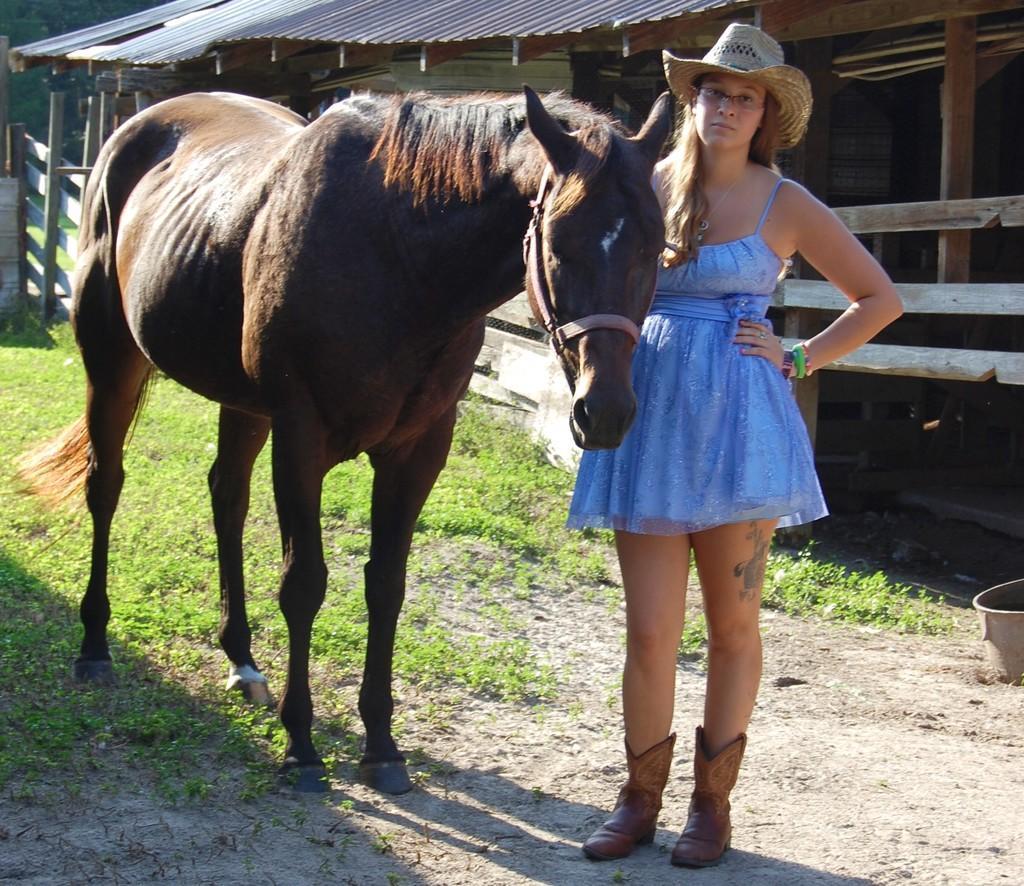Describe this image in one or two sentences. A horse and a lady, lady who is wearing a blue gown and a hat. Behind them there is a roof like shade and also some grass under the horse. 